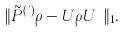Convert formula to latex. <formula><loc_0><loc_0><loc_500><loc_500>\| \tilde { P } ^ { \left ( i \right ) } \rho - U \rho U ^ { \dag } \| _ { 1 } .</formula> 